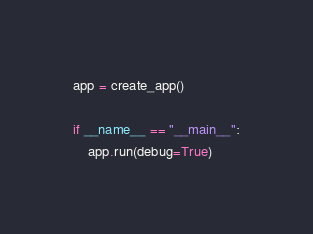<code> <loc_0><loc_0><loc_500><loc_500><_Python_>
app = create_app()

if __name__ == "__main__":
    app.run(debug=True)
</code> 